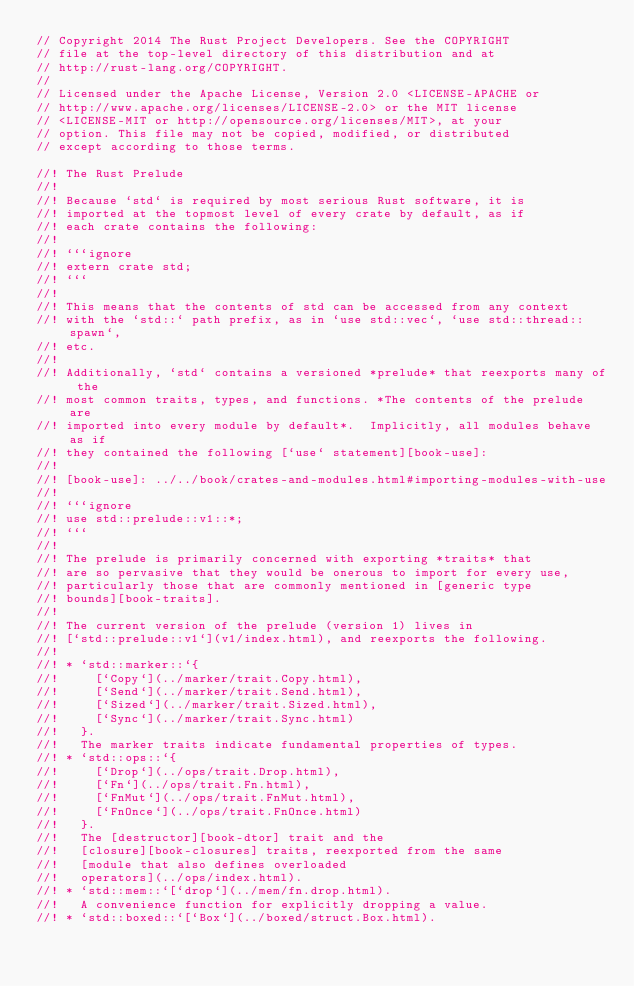Convert code to text. <code><loc_0><loc_0><loc_500><loc_500><_Rust_>// Copyright 2014 The Rust Project Developers. See the COPYRIGHT
// file at the top-level directory of this distribution and at
// http://rust-lang.org/COPYRIGHT.
//
// Licensed under the Apache License, Version 2.0 <LICENSE-APACHE or
// http://www.apache.org/licenses/LICENSE-2.0> or the MIT license
// <LICENSE-MIT or http://opensource.org/licenses/MIT>, at your
// option. This file may not be copied, modified, or distributed
// except according to those terms.

//! The Rust Prelude
//!
//! Because `std` is required by most serious Rust software, it is
//! imported at the topmost level of every crate by default, as if
//! each crate contains the following:
//!
//! ```ignore
//! extern crate std;
//! ```
//!
//! This means that the contents of std can be accessed from any context
//! with the `std::` path prefix, as in `use std::vec`, `use std::thread::spawn`,
//! etc.
//!
//! Additionally, `std` contains a versioned *prelude* that reexports many of the
//! most common traits, types, and functions. *The contents of the prelude are
//! imported into every module by default*.  Implicitly, all modules behave as if
//! they contained the following [`use` statement][book-use]:
//!
//! [book-use]: ../../book/crates-and-modules.html#importing-modules-with-use
//!
//! ```ignore
//! use std::prelude::v1::*;
//! ```
//!
//! The prelude is primarily concerned with exporting *traits* that
//! are so pervasive that they would be onerous to import for every use,
//! particularly those that are commonly mentioned in [generic type
//! bounds][book-traits].
//!
//! The current version of the prelude (version 1) lives in
//! [`std::prelude::v1`](v1/index.html), and reexports the following.
//!
//! * `std::marker::`{
//!     [`Copy`](../marker/trait.Copy.html),
//!     [`Send`](../marker/trait.Send.html),
//!     [`Sized`](../marker/trait.Sized.html),
//!     [`Sync`](../marker/trait.Sync.html)
//!   }.
//!   The marker traits indicate fundamental properties of types.
//! * `std::ops::`{
//!     [`Drop`](../ops/trait.Drop.html),
//!     [`Fn`](../ops/trait.Fn.html),
//!     [`FnMut`](../ops/trait.FnMut.html),
//!     [`FnOnce`](../ops/trait.FnOnce.html)
//!   }.
//!   The [destructor][book-dtor] trait and the
//!   [closure][book-closures] traits, reexported from the same
//!   [module that also defines overloaded
//!   operators](../ops/index.html).
//! * `std::mem::`[`drop`](../mem/fn.drop.html).
//!   A convenience function for explicitly dropping a value.
//! * `std::boxed::`[`Box`](../boxed/struct.Box.html).</code> 